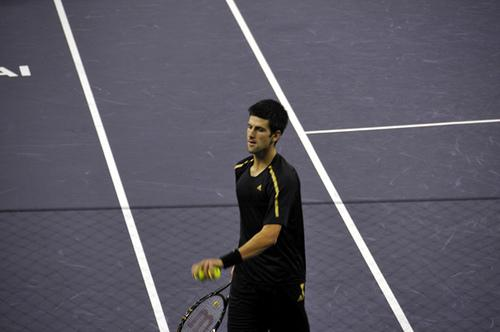Name a standout detail on the tennis racket and the color of its strings. A standout detail on the tennis racket is a "W" letter, and its strings are white. Describe the court's appearance, including its color and lines. The tennis court has a blue ground with white lines, and there is a white stripe on it. Mention the style of the tennis player's hair and the color of the wristband he's wearing. The tennis player has short black hair, and he is wearing a black cloth wristband. Describe any shadows present in the image and their origin. There is a shadow of a chain-link fence cast on the tennis court. Count the number of tennis balls in the hand of the tennis player. There are two tennis balls in the hand of the tennis player. Explain how the image can give the impression that the person is currently playing tennis.  The tennis player is holding a racket and tennis balls, wearing a uniform and walking on a tennis court, indicating that he is playing tennis. What is unique about the tennis racket in the image, and what is on its strings? The tennis racket is black, gold, and white with a "W" letter on its strings. What is the color of the shorts the man is wearing, and mention any other clothing he has on. The man is wearing black shorts and a short-sleeved black tee shirt. What color is the tennis player's shirt and what distinctive feature does it have? The tennis player's shirt is black with a yellow stripe and a gold logo on it. Can you identify two objects that the person in the image is holding?  The person is holding two yellow tennis balls and a yellow and black racket.  Identify the number printed on the back of the man's shirt and describe the font style. None of the captions mention a number or any writing on the back of the man's shirt. This instruction is misleading because it asks the viewer to search for non-existent information on the man's shirt and describe a non-existent font style. Can you spot a red cap on the man's head and observe its shape? There is no mention of a red cap or any headwear on the man in the provided image captions. This instruction is misleading because it asks the viewer to search for a non-existent object and comment on its shape. Examine the way the sunlight hits the green trees behind the fence and creates shadows. The mentioned captions don't discuss any green trees or sunlight. This instruction is misleading because it implies that there are trees and sunlight depicted in the image, when they are not mentioned in the provided information. Do you see a water bottle on the side of the court? What color is it? There is no mention of a water bottle or anything on the side of the court in the provided captions. This instruction is misleading because it asks the viewer to find a non-existent object and identify its color. Notice how the blue sneakers contrast with the court and describe the pattern on them. No, it's not mentioned in the image. Look for a small dog near the tennis court and describe its fur color. There is no mention of a dog or any animals in the provided captions. This instruction is misleading because it asks the viewer to find a non-existent object and describe its fur color. 